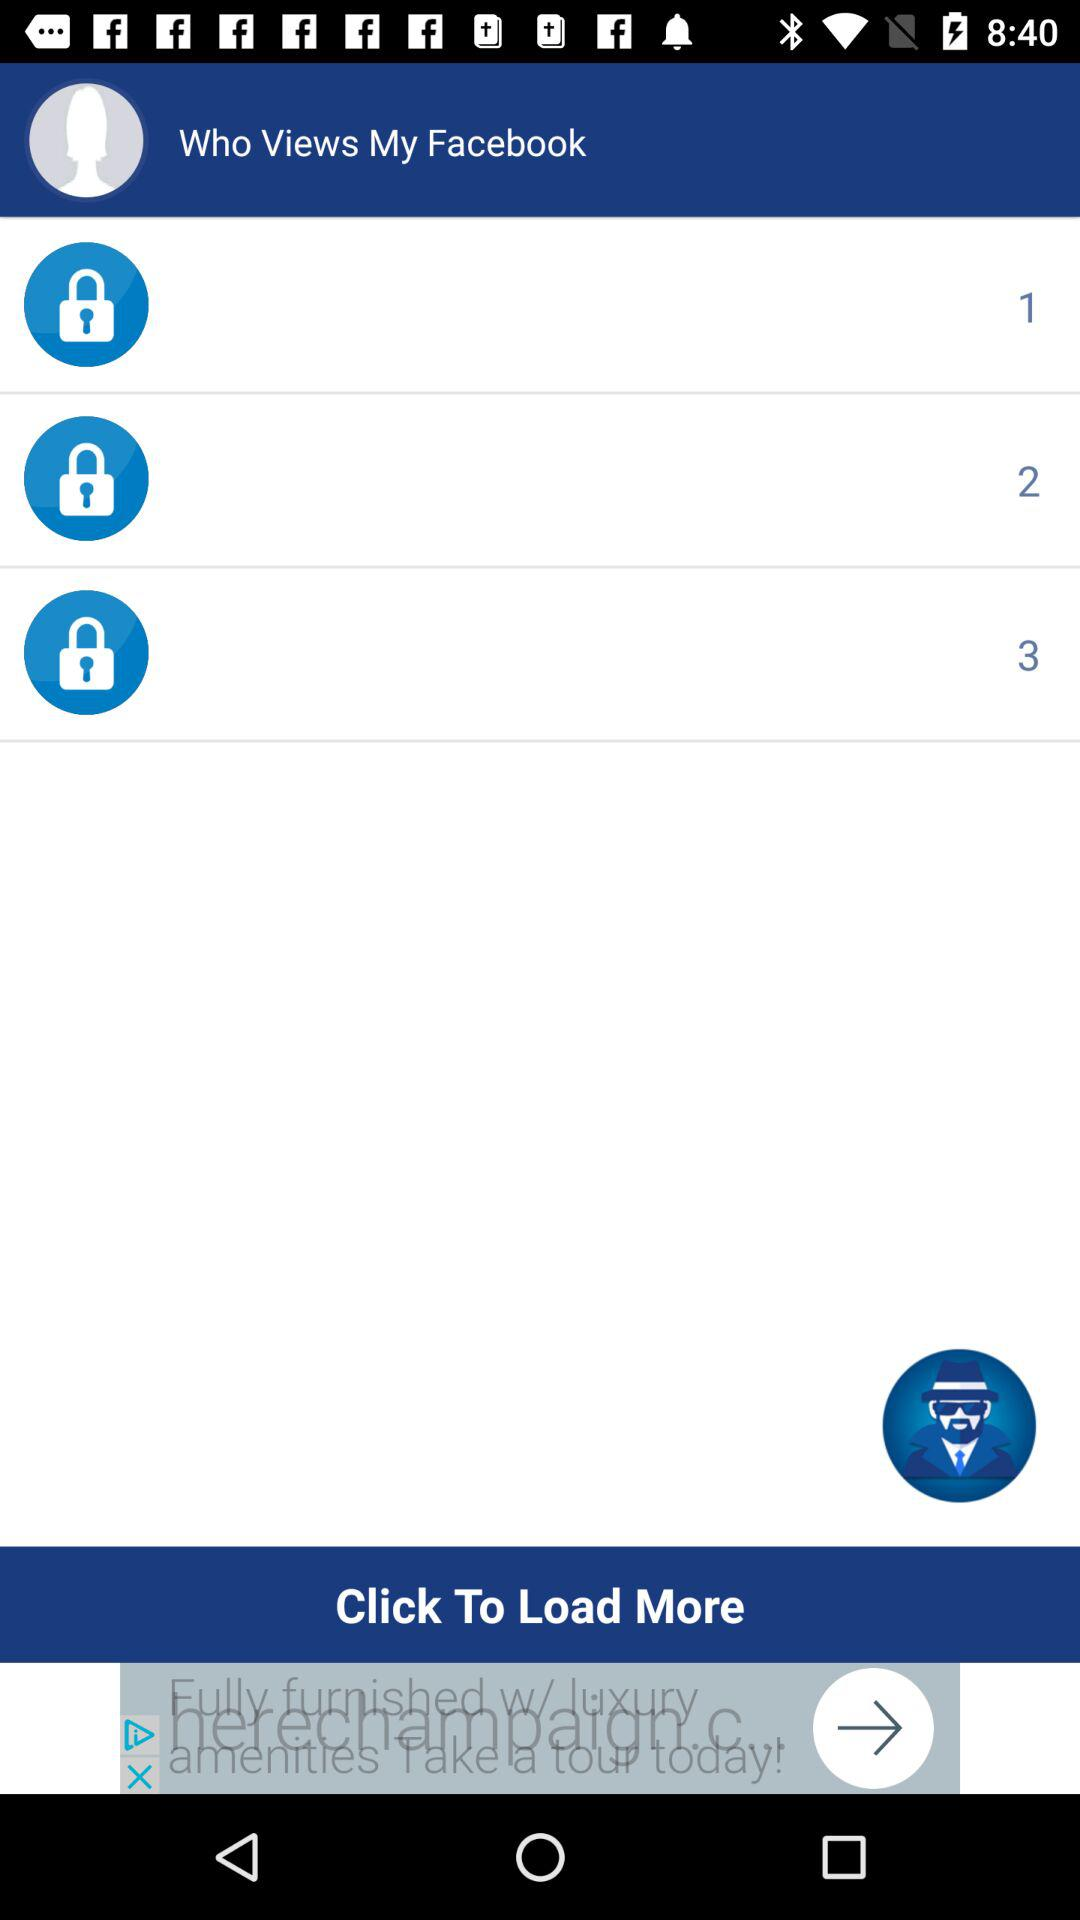How many people have viewed my Facebook?
Answer the question using a single word or phrase. 3 